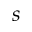Convert formula to latex. <formula><loc_0><loc_0><loc_500><loc_500>s</formula> 